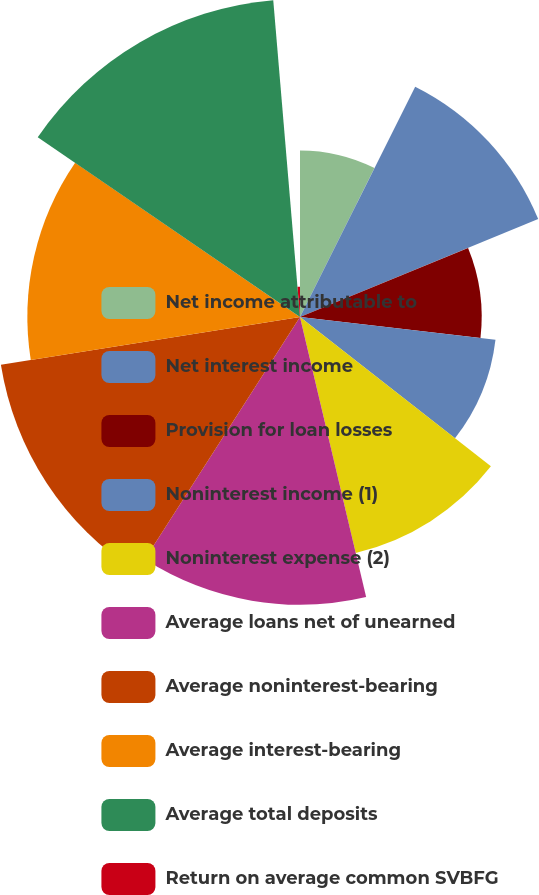Convert chart. <chart><loc_0><loc_0><loc_500><loc_500><pie_chart><fcel>Net income attributable to<fcel>Net interest income<fcel>Provision for loan losses<fcel>Noninterest income (1)<fcel>Noninterest expense (2)<fcel>Average loans net of unearned<fcel>Average noninterest-bearing<fcel>Average interest-bearing<fcel>Average total deposits<fcel>Return on average common SVBFG<nl><fcel>7.38%<fcel>11.41%<fcel>8.05%<fcel>8.72%<fcel>10.74%<fcel>12.75%<fcel>13.42%<fcel>12.08%<fcel>14.09%<fcel>1.34%<nl></chart> 